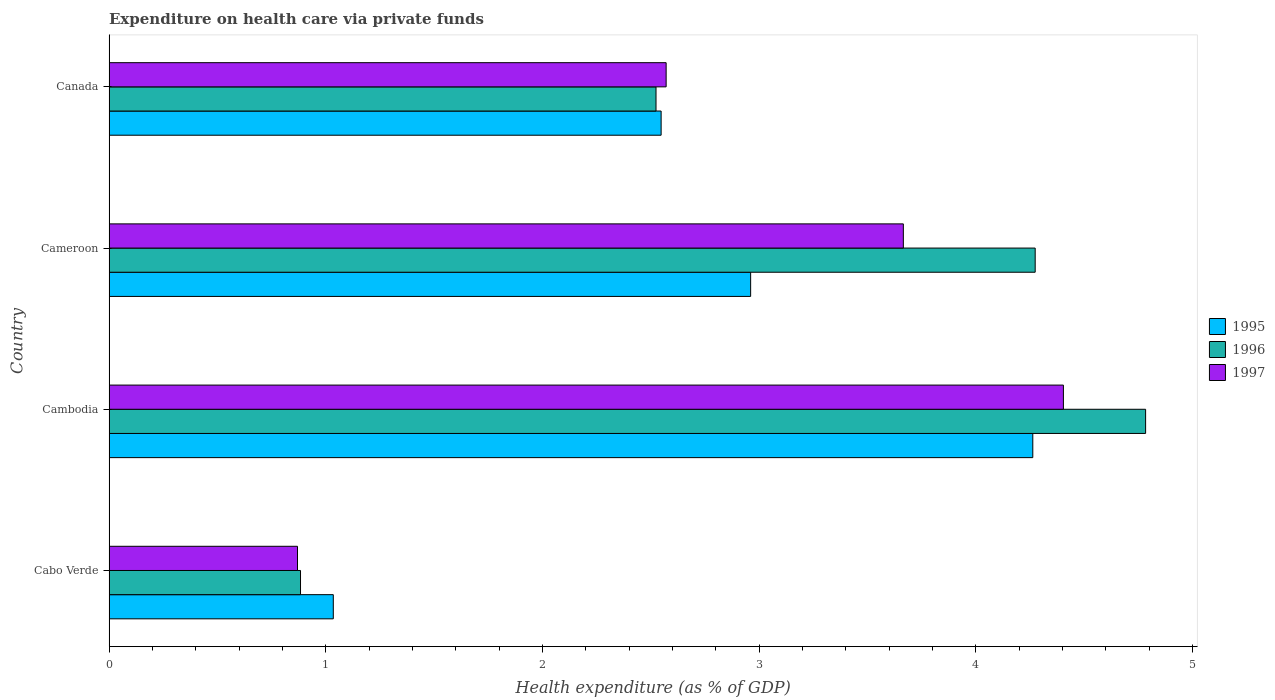How many different coloured bars are there?
Give a very brief answer. 3. How many groups of bars are there?
Provide a short and direct response. 4. How many bars are there on the 1st tick from the bottom?
Provide a succinct answer. 3. What is the label of the 1st group of bars from the top?
Your answer should be very brief. Canada. What is the expenditure made on health care in 1997 in Cambodia?
Your response must be concise. 4.4. Across all countries, what is the maximum expenditure made on health care in 1995?
Offer a very short reply. 4.26. Across all countries, what is the minimum expenditure made on health care in 1997?
Provide a short and direct response. 0.87. In which country was the expenditure made on health care in 1995 maximum?
Provide a succinct answer. Cambodia. In which country was the expenditure made on health care in 1997 minimum?
Ensure brevity in your answer.  Cabo Verde. What is the total expenditure made on health care in 1997 in the graph?
Make the answer very short. 11.51. What is the difference between the expenditure made on health care in 1995 in Cabo Verde and that in Cambodia?
Give a very brief answer. -3.23. What is the difference between the expenditure made on health care in 1996 in Canada and the expenditure made on health care in 1997 in Cambodia?
Ensure brevity in your answer.  -1.88. What is the average expenditure made on health care in 1996 per country?
Give a very brief answer. 3.12. What is the difference between the expenditure made on health care in 1996 and expenditure made on health care in 1995 in Canada?
Offer a terse response. -0.02. What is the ratio of the expenditure made on health care in 1997 in Cameroon to that in Canada?
Your answer should be very brief. 1.43. Is the difference between the expenditure made on health care in 1996 in Cambodia and Canada greater than the difference between the expenditure made on health care in 1995 in Cambodia and Canada?
Give a very brief answer. Yes. What is the difference between the highest and the second highest expenditure made on health care in 1995?
Provide a succinct answer. 1.3. What is the difference between the highest and the lowest expenditure made on health care in 1996?
Offer a terse response. 3.9. What does the 3rd bar from the bottom in Cameroon represents?
Offer a terse response. 1997. Is it the case that in every country, the sum of the expenditure made on health care in 1997 and expenditure made on health care in 1995 is greater than the expenditure made on health care in 1996?
Provide a short and direct response. Yes. Are all the bars in the graph horizontal?
Ensure brevity in your answer.  Yes. What is the difference between two consecutive major ticks on the X-axis?
Provide a succinct answer. 1. Does the graph contain any zero values?
Your answer should be compact. No. Where does the legend appear in the graph?
Offer a very short reply. Center right. What is the title of the graph?
Offer a very short reply. Expenditure on health care via private funds. What is the label or title of the X-axis?
Keep it short and to the point. Health expenditure (as % of GDP). What is the Health expenditure (as % of GDP) of 1995 in Cabo Verde?
Offer a very short reply. 1.03. What is the Health expenditure (as % of GDP) in 1996 in Cabo Verde?
Offer a terse response. 0.88. What is the Health expenditure (as % of GDP) in 1997 in Cabo Verde?
Provide a succinct answer. 0.87. What is the Health expenditure (as % of GDP) of 1995 in Cambodia?
Your answer should be very brief. 4.26. What is the Health expenditure (as % of GDP) of 1996 in Cambodia?
Offer a terse response. 4.78. What is the Health expenditure (as % of GDP) of 1997 in Cambodia?
Offer a terse response. 4.4. What is the Health expenditure (as % of GDP) of 1995 in Cameroon?
Provide a short and direct response. 2.96. What is the Health expenditure (as % of GDP) in 1996 in Cameroon?
Keep it short and to the point. 4.27. What is the Health expenditure (as % of GDP) in 1997 in Cameroon?
Ensure brevity in your answer.  3.67. What is the Health expenditure (as % of GDP) of 1995 in Canada?
Your answer should be very brief. 2.55. What is the Health expenditure (as % of GDP) of 1996 in Canada?
Make the answer very short. 2.52. What is the Health expenditure (as % of GDP) in 1997 in Canada?
Ensure brevity in your answer.  2.57. Across all countries, what is the maximum Health expenditure (as % of GDP) in 1995?
Offer a terse response. 4.26. Across all countries, what is the maximum Health expenditure (as % of GDP) of 1996?
Ensure brevity in your answer.  4.78. Across all countries, what is the maximum Health expenditure (as % of GDP) in 1997?
Offer a terse response. 4.4. Across all countries, what is the minimum Health expenditure (as % of GDP) in 1995?
Your answer should be compact. 1.03. Across all countries, what is the minimum Health expenditure (as % of GDP) of 1996?
Provide a short and direct response. 0.88. Across all countries, what is the minimum Health expenditure (as % of GDP) of 1997?
Provide a short and direct response. 0.87. What is the total Health expenditure (as % of GDP) in 1995 in the graph?
Your answer should be very brief. 10.81. What is the total Health expenditure (as % of GDP) of 1996 in the graph?
Your answer should be very brief. 12.47. What is the total Health expenditure (as % of GDP) of 1997 in the graph?
Ensure brevity in your answer.  11.51. What is the difference between the Health expenditure (as % of GDP) in 1995 in Cabo Verde and that in Cambodia?
Your answer should be very brief. -3.23. What is the difference between the Health expenditure (as % of GDP) of 1996 in Cabo Verde and that in Cambodia?
Offer a terse response. -3.9. What is the difference between the Health expenditure (as % of GDP) in 1997 in Cabo Verde and that in Cambodia?
Your response must be concise. -3.53. What is the difference between the Health expenditure (as % of GDP) of 1995 in Cabo Verde and that in Cameroon?
Give a very brief answer. -1.93. What is the difference between the Health expenditure (as % of GDP) in 1996 in Cabo Verde and that in Cameroon?
Provide a short and direct response. -3.39. What is the difference between the Health expenditure (as % of GDP) in 1997 in Cabo Verde and that in Cameroon?
Your answer should be compact. -2.8. What is the difference between the Health expenditure (as % of GDP) of 1995 in Cabo Verde and that in Canada?
Your answer should be compact. -1.51. What is the difference between the Health expenditure (as % of GDP) in 1996 in Cabo Verde and that in Canada?
Ensure brevity in your answer.  -1.64. What is the difference between the Health expenditure (as % of GDP) of 1997 in Cabo Verde and that in Canada?
Offer a very short reply. -1.7. What is the difference between the Health expenditure (as % of GDP) of 1995 in Cambodia and that in Cameroon?
Provide a succinct answer. 1.3. What is the difference between the Health expenditure (as % of GDP) of 1996 in Cambodia and that in Cameroon?
Keep it short and to the point. 0.51. What is the difference between the Health expenditure (as % of GDP) of 1997 in Cambodia and that in Cameroon?
Provide a succinct answer. 0.74. What is the difference between the Health expenditure (as % of GDP) in 1995 in Cambodia and that in Canada?
Provide a succinct answer. 1.72. What is the difference between the Health expenditure (as % of GDP) of 1996 in Cambodia and that in Canada?
Provide a short and direct response. 2.26. What is the difference between the Health expenditure (as % of GDP) of 1997 in Cambodia and that in Canada?
Provide a short and direct response. 1.83. What is the difference between the Health expenditure (as % of GDP) of 1995 in Cameroon and that in Canada?
Your answer should be compact. 0.41. What is the difference between the Health expenditure (as % of GDP) of 1996 in Cameroon and that in Canada?
Keep it short and to the point. 1.75. What is the difference between the Health expenditure (as % of GDP) of 1997 in Cameroon and that in Canada?
Your response must be concise. 1.09. What is the difference between the Health expenditure (as % of GDP) in 1995 in Cabo Verde and the Health expenditure (as % of GDP) in 1996 in Cambodia?
Your answer should be compact. -3.75. What is the difference between the Health expenditure (as % of GDP) of 1995 in Cabo Verde and the Health expenditure (as % of GDP) of 1997 in Cambodia?
Make the answer very short. -3.37. What is the difference between the Health expenditure (as % of GDP) in 1996 in Cabo Verde and the Health expenditure (as % of GDP) in 1997 in Cambodia?
Offer a terse response. -3.52. What is the difference between the Health expenditure (as % of GDP) in 1995 in Cabo Verde and the Health expenditure (as % of GDP) in 1996 in Cameroon?
Offer a very short reply. -3.24. What is the difference between the Health expenditure (as % of GDP) in 1995 in Cabo Verde and the Health expenditure (as % of GDP) in 1997 in Cameroon?
Ensure brevity in your answer.  -2.63. What is the difference between the Health expenditure (as % of GDP) of 1996 in Cabo Verde and the Health expenditure (as % of GDP) of 1997 in Cameroon?
Your response must be concise. -2.78. What is the difference between the Health expenditure (as % of GDP) of 1995 in Cabo Verde and the Health expenditure (as % of GDP) of 1996 in Canada?
Provide a short and direct response. -1.49. What is the difference between the Health expenditure (as % of GDP) in 1995 in Cabo Verde and the Health expenditure (as % of GDP) in 1997 in Canada?
Ensure brevity in your answer.  -1.54. What is the difference between the Health expenditure (as % of GDP) in 1996 in Cabo Verde and the Health expenditure (as % of GDP) in 1997 in Canada?
Keep it short and to the point. -1.69. What is the difference between the Health expenditure (as % of GDP) of 1995 in Cambodia and the Health expenditure (as % of GDP) of 1996 in Cameroon?
Offer a very short reply. -0.01. What is the difference between the Health expenditure (as % of GDP) in 1995 in Cambodia and the Health expenditure (as % of GDP) in 1997 in Cameroon?
Keep it short and to the point. 0.6. What is the difference between the Health expenditure (as % of GDP) in 1996 in Cambodia and the Health expenditure (as % of GDP) in 1997 in Cameroon?
Offer a terse response. 1.12. What is the difference between the Health expenditure (as % of GDP) in 1995 in Cambodia and the Health expenditure (as % of GDP) in 1996 in Canada?
Your answer should be compact. 1.74. What is the difference between the Health expenditure (as % of GDP) in 1995 in Cambodia and the Health expenditure (as % of GDP) in 1997 in Canada?
Make the answer very short. 1.69. What is the difference between the Health expenditure (as % of GDP) of 1996 in Cambodia and the Health expenditure (as % of GDP) of 1997 in Canada?
Provide a succinct answer. 2.21. What is the difference between the Health expenditure (as % of GDP) of 1995 in Cameroon and the Health expenditure (as % of GDP) of 1996 in Canada?
Provide a short and direct response. 0.44. What is the difference between the Health expenditure (as % of GDP) in 1995 in Cameroon and the Health expenditure (as % of GDP) in 1997 in Canada?
Keep it short and to the point. 0.39. What is the difference between the Health expenditure (as % of GDP) of 1996 in Cameroon and the Health expenditure (as % of GDP) of 1997 in Canada?
Provide a short and direct response. 1.7. What is the average Health expenditure (as % of GDP) of 1995 per country?
Give a very brief answer. 2.7. What is the average Health expenditure (as % of GDP) in 1996 per country?
Ensure brevity in your answer.  3.12. What is the average Health expenditure (as % of GDP) of 1997 per country?
Offer a very short reply. 2.88. What is the difference between the Health expenditure (as % of GDP) in 1995 and Health expenditure (as % of GDP) in 1996 in Cabo Verde?
Ensure brevity in your answer.  0.15. What is the difference between the Health expenditure (as % of GDP) of 1995 and Health expenditure (as % of GDP) of 1997 in Cabo Verde?
Offer a terse response. 0.17. What is the difference between the Health expenditure (as % of GDP) of 1996 and Health expenditure (as % of GDP) of 1997 in Cabo Verde?
Provide a succinct answer. 0.01. What is the difference between the Health expenditure (as % of GDP) in 1995 and Health expenditure (as % of GDP) in 1996 in Cambodia?
Your response must be concise. -0.52. What is the difference between the Health expenditure (as % of GDP) in 1995 and Health expenditure (as % of GDP) in 1997 in Cambodia?
Give a very brief answer. -0.14. What is the difference between the Health expenditure (as % of GDP) in 1996 and Health expenditure (as % of GDP) in 1997 in Cambodia?
Make the answer very short. 0.38. What is the difference between the Health expenditure (as % of GDP) in 1995 and Health expenditure (as % of GDP) in 1996 in Cameroon?
Make the answer very short. -1.31. What is the difference between the Health expenditure (as % of GDP) in 1995 and Health expenditure (as % of GDP) in 1997 in Cameroon?
Provide a succinct answer. -0.7. What is the difference between the Health expenditure (as % of GDP) in 1996 and Health expenditure (as % of GDP) in 1997 in Cameroon?
Your answer should be very brief. 0.61. What is the difference between the Health expenditure (as % of GDP) of 1995 and Health expenditure (as % of GDP) of 1996 in Canada?
Provide a short and direct response. 0.02. What is the difference between the Health expenditure (as % of GDP) of 1995 and Health expenditure (as % of GDP) of 1997 in Canada?
Make the answer very short. -0.02. What is the difference between the Health expenditure (as % of GDP) in 1996 and Health expenditure (as % of GDP) in 1997 in Canada?
Provide a short and direct response. -0.05. What is the ratio of the Health expenditure (as % of GDP) of 1995 in Cabo Verde to that in Cambodia?
Offer a very short reply. 0.24. What is the ratio of the Health expenditure (as % of GDP) in 1996 in Cabo Verde to that in Cambodia?
Provide a succinct answer. 0.18. What is the ratio of the Health expenditure (as % of GDP) of 1997 in Cabo Verde to that in Cambodia?
Your response must be concise. 0.2. What is the ratio of the Health expenditure (as % of GDP) in 1995 in Cabo Verde to that in Cameroon?
Offer a terse response. 0.35. What is the ratio of the Health expenditure (as % of GDP) in 1996 in Cabo Verde to that in Cameroon?
Your answer should be compact. 0.21. What is the ratio of the Health expenditure (as % of GDP) of 1997 in Cabo Verde to that in Cameroon?
Give a very brief answer. 0.24. What is the ratio of the Health expenditure (as % of GDP) in 1995 in Cabo Verde to that in Canada?
Provide a succinct answer. 0.41. What is the ratio of the Health expenditure (as % of GDP) of 1996 in Cabo Verde to that in Canada?
Give a very brief answer. 0.35. What is the ratio of the Health expenditure (as % of GDP) of 1997 in Cabo Verde to that in Canada?
Your answer should be very brief. 0.34. What is the ratio of the Health expenditure (as % of GDP) of 1995 in Cambodia to that in Cameroon?
Provide a succinct answer. 1.44. What is the ratio of the Health expenditure (as % of GDP) in 1996 in Cambodia to that in Cameroon?
Keep it short and to the point. 1.12. What is the ratio of the Health expenditure (as % of GDP) in 1997 in Cambodia to that in Cameroon?
Offer a terse response. 1.2. What is the ratio of the Health expenditure (as % of GDP) in 1995 in Cambodia to that in Canada?
Provide a short and direct response. 1.67. What is the ratio of the Health expenditure (as % of GDP) of 1996 in Cambodia to that in Canada?
Offer a terse response. 1.9. What is the ratio of the Health expenditure (as % of GDP) in 1997 in Cambodia to that in Canada?
Provide a succinct answer. 1.71. What is the ratio of the Health expenditure (as % of GDP) in 1995 in Cameroon to that in Canada?
Provide a short and direct response. 1.16. What is the ratio of the Health expenditure (as % of GDP) in 1996 in Cameroon to that in Canada?
Give a very brief answer. 1.69. What is the ratio of the Health expenditure (as % of GDP) in 1997 in Cameroon to that in Canada?
Offer a terse response. 1.43. What is the difference between the highest and the second highest Health expenditure (as % of GDP) in 1995?
Your answer should be very brief. 1.3. What is the difference between the highest and the second highest Health expenditure (as % of GDP) in 1996?
Give a very brief answer. 0.51. What is the difference between the highest and the second highest Health expenditure (as % of GDP) in 1997?
Make the answer very short. 0.74. What is the difference between the highest and the lowest Health expenditure (as % of GDP) of 1995?
Your response must be concise. 3.23. What is the difference between the highest and the lowest Health expenditure (as % of GDP) in 1996?
Ensure brevity in your answer.  3.9. What is the difference between the highest and the lowest Health expenditure (as % of GDP) in 1997?
Give a very brief answer. 3.53. 